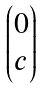Convert formula to latex. <formula><loc_0><loc_0><loc_500><loc_500>\begin{pmatrix} 0 \\ c \end{pmatrix}</formula> 